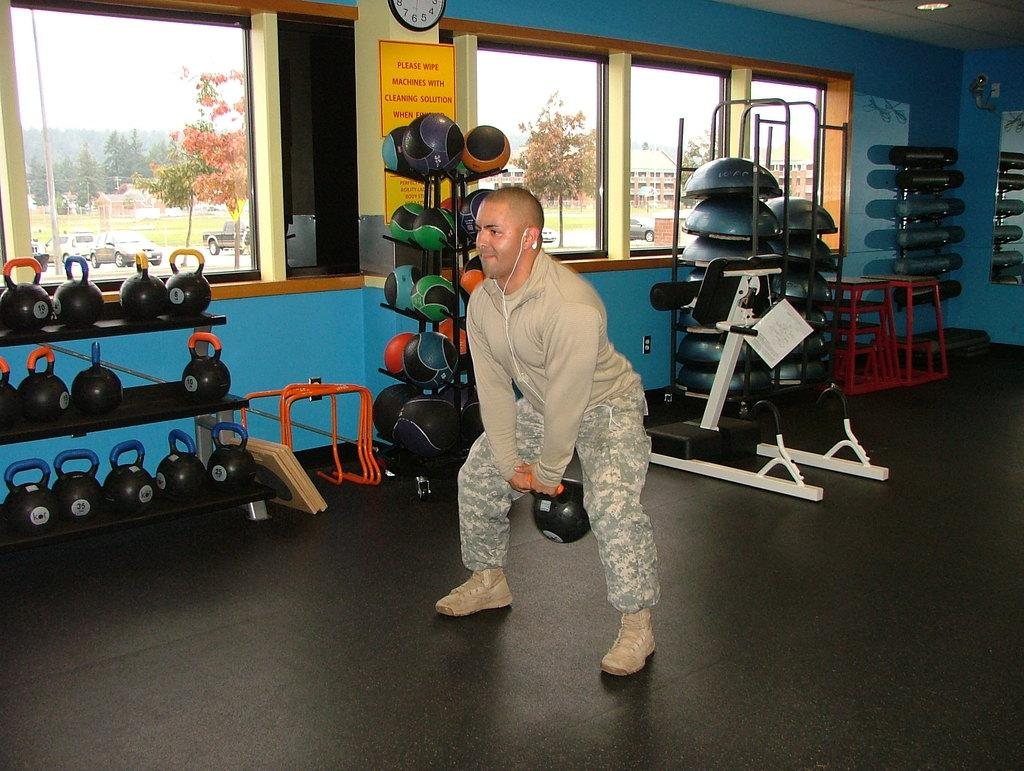<image>
Offer a succinct explanation of the picture presented. A man does exercises in a gym with a sign on the wall asking people to wipe down machines after use. 